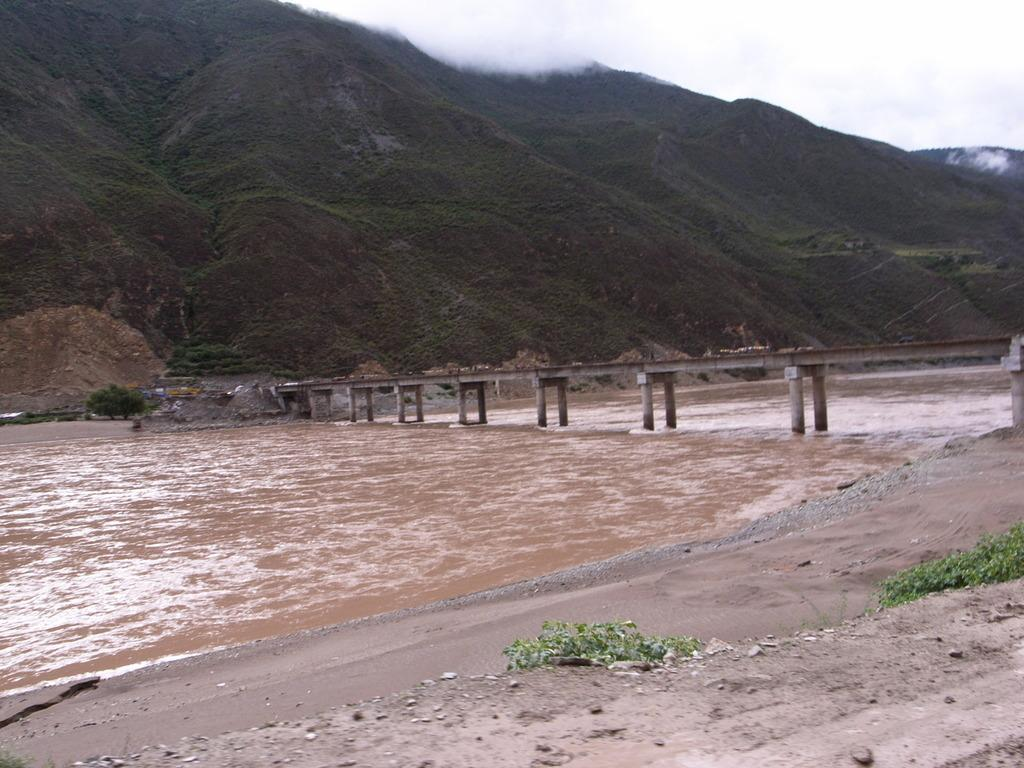What type of structure is present in the image? There is a bridge with pillars in the image. What can be seen flowing beneath the bridge? There is water visible in the image. Are there any natural elements present in the image? Yes, there are plants in the image. What is visible in the distance behind the bridge? There is a hill in the background of the image. How many quarters can be seen on the bridge in the image? There are no quarters visible in the image; it features a bridge with pillars, water, plants, and a hill in the background. What type of home is present on the bridge in the image? There is no home present on the bridge in the image. 